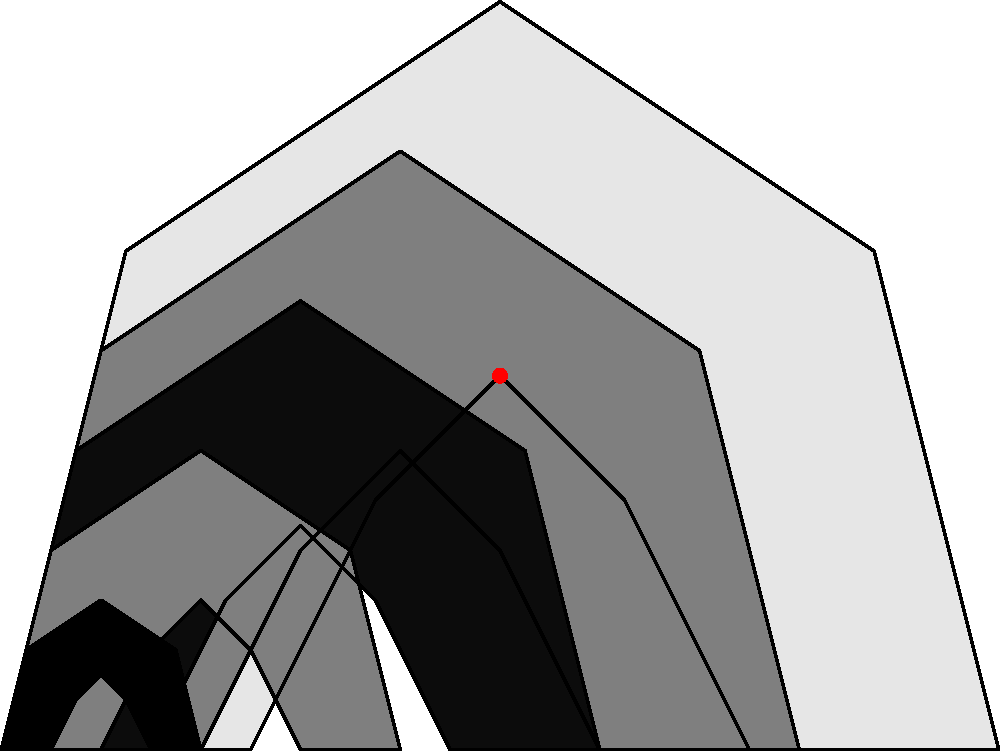At your local shooting range, you encounter a unique Texas-shaped target with concentric scoring rings. Analyzing the symmetry group of this target, how many distinct symmetry operations (including the identity) does it possess? Let's approach this step-by-step:

1) First, we need to identify the symmetries of the Texas-shaped target:

   a) Rotational symmetry: The shape doesn't have any rotational symmetry other than the identity (360° rotation).
   
   b) Reflection symmetry: There is one line of reflection symmetry, vertically bisecting the shape.

2) Now, let's count the symmetry operations:

   a) Identity transformation (doing nothing): 1 operation
   
   b) Reflection across the vertical line: 1 operation

3) In group theory, the set of these symmetry operations forms a group under composition. This group is isomorphic to the Cyclic group $C_2$ or the Dihedral group $D_1$.

4) The order of this group (number of elements) is the total number of distinct symmetry operations.

5) Therefore, we have 1 (identity) + 1 (reflection) = 2 distinct symmetry operations.
Answer: 2 